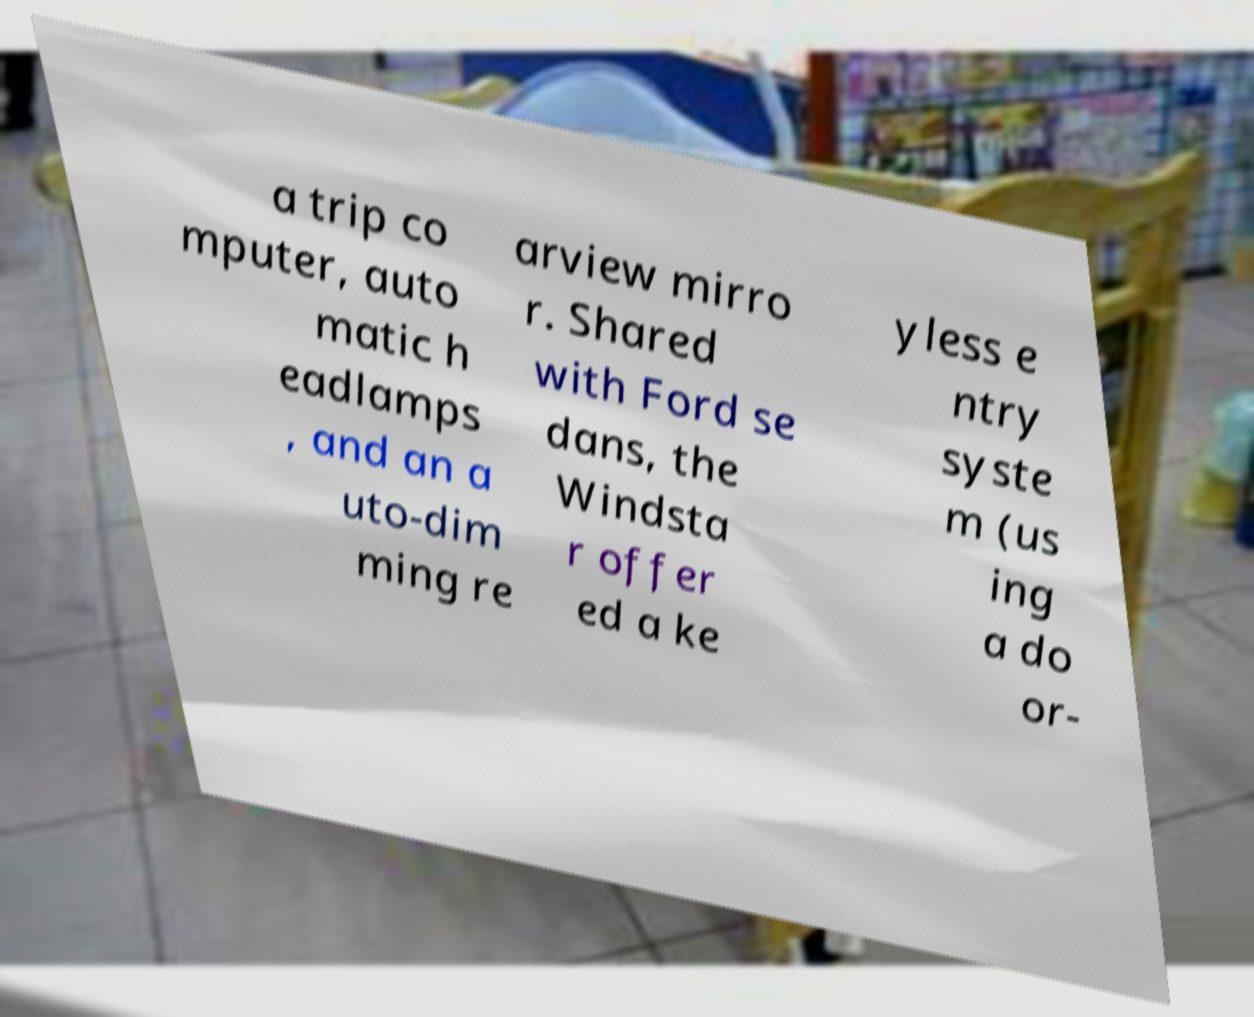Please identify and transcribe the text found in this image. a trip co mputer, auto matic h eadlamps , and an a uto-dim ming re arview mirro r. Shared with Ford se dans, the Windsta r offer ed a ke yless e ntry syste m (us ing a do or- 